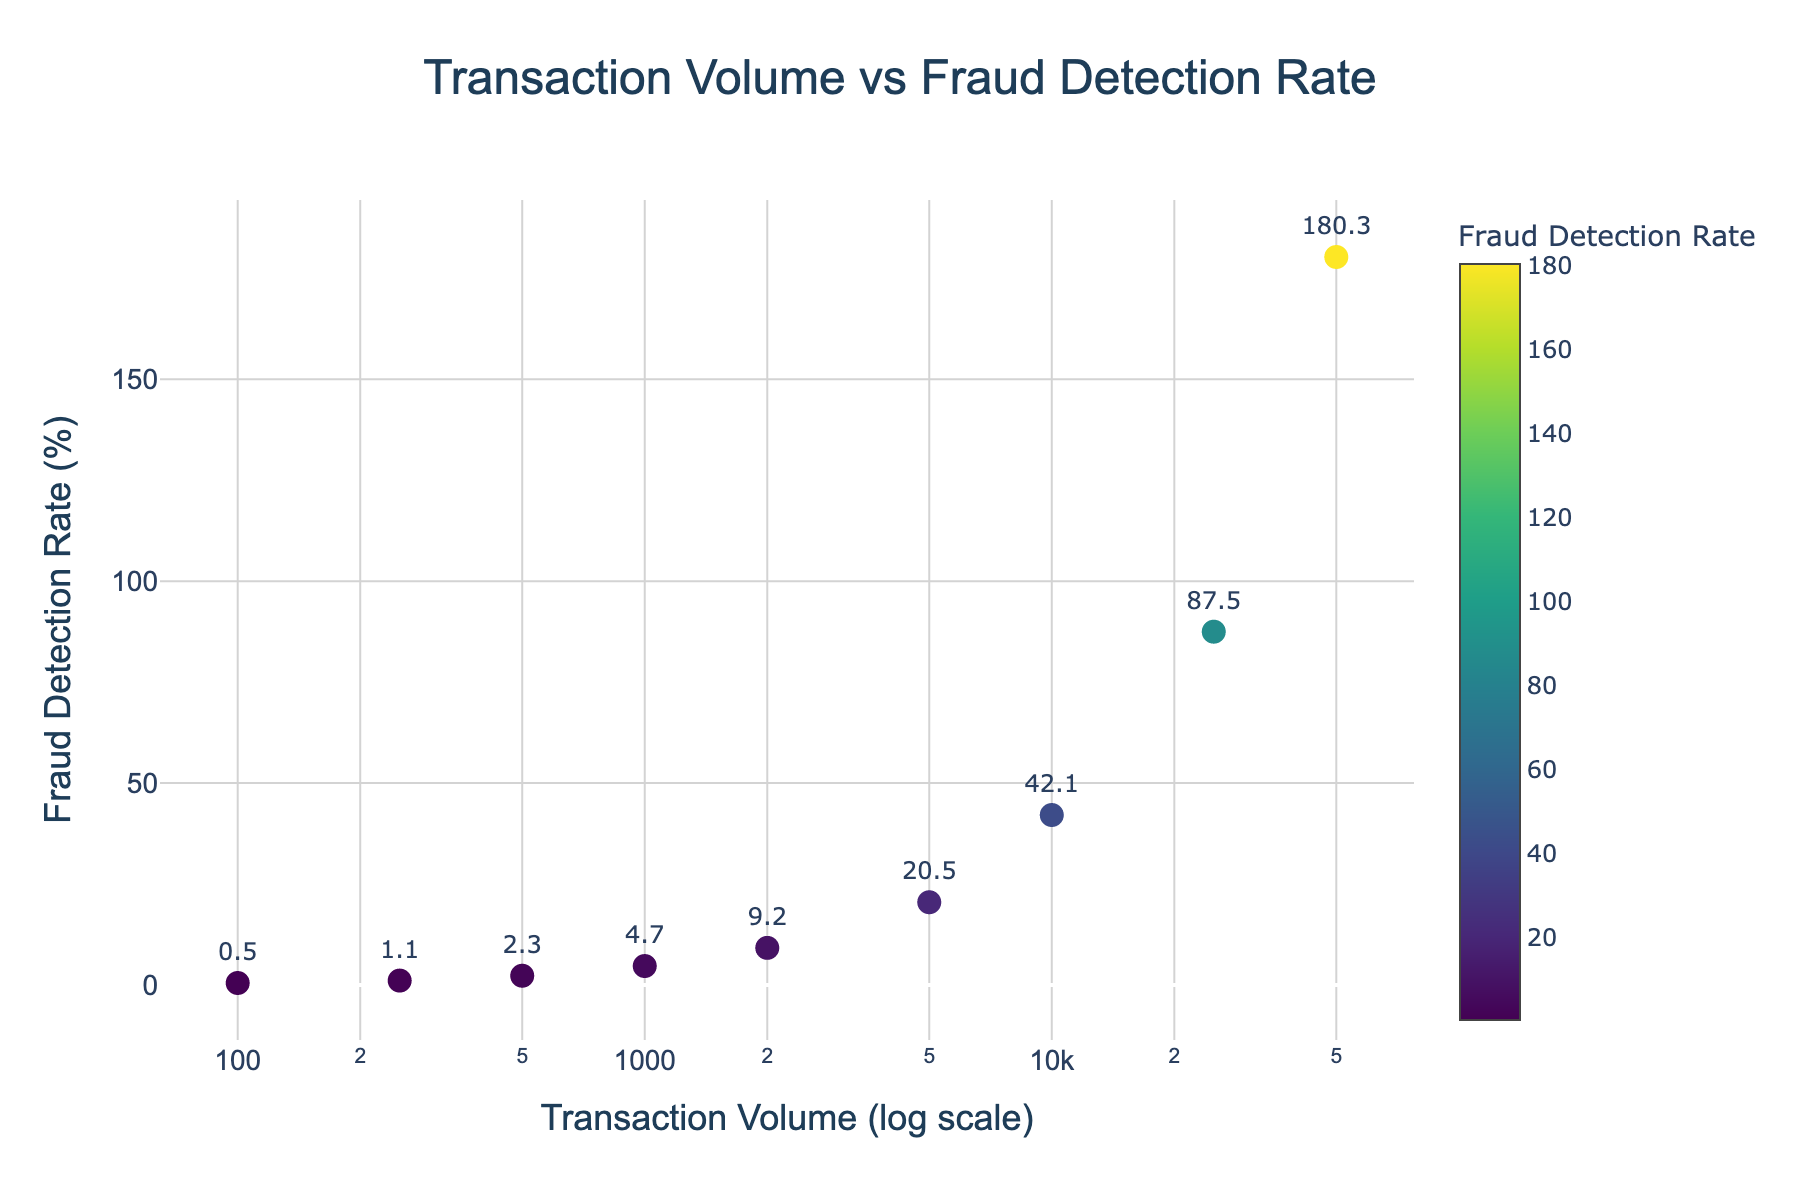How many data points are plotted in the scatter plot? There are nine data points given in the data set, which are plotted in the scatter plot.
Answer: 9 What is the title of the scatter plot? The title of the scatter plot is mentioned at the top of the figure.
Answer: Transaction Volume vs Fraud Detection Rate What are the axes labels in the scatter plot? The x-axis is labeled "Transaction Volume (log scale)" and the y-axis is labeled "Fraud Detection Rate (%)".
Answer: Transaction Volume (log scale), Fraud Detection Rate (%) Which data point has the highest fraud detection rate? The data point with the highest fraud detection rate can be identified by the highest value on the y-axis.
Answer: Transaction Volume: 50000, Fraud Detection Rate: 180.3 What is the fraud detection rate when the transaction volume is 1000? We look at the data point where the transaction volume is 1000 and read the corresponding fraud detection rate from the figure.
Answer: 4.7 Compare the fraud detection rates for transaction volumes of 5000 and 10000. Which is higher? We need to look at the fraud detection rates for both transaction volumes and compare them. For 5000, it's 20.5, and for 10000, it's 42.1.
Answer: 42.1 is higher What is the general trend observed between transaction volume and fraud detection rates? As the transaction volume increases, the fraud detection rate also increases. This conclusion is drawn from the upward trajectory of the data points.
Answer: Increasing trend What is the percentage increase in fraud detection rate from a transaction volume of 2500 to 5000? The fraud detection rate at 2500 transactions is approximately halfway between 1.1% and 2.3%. At 5000, it is 20.5%. The approximate half-point is 1.7%. So the percentage increase is ((20.5 - 1.7) / 1.7) * 100.
Answer: Over 1100% Is the relationship between transaction volume and fraud detection rate linear or non-linear? The relationship appears non-linear because the rate of increase in fraud detection rate accelerates as transaction volume increases.
Answer: Non-linear 